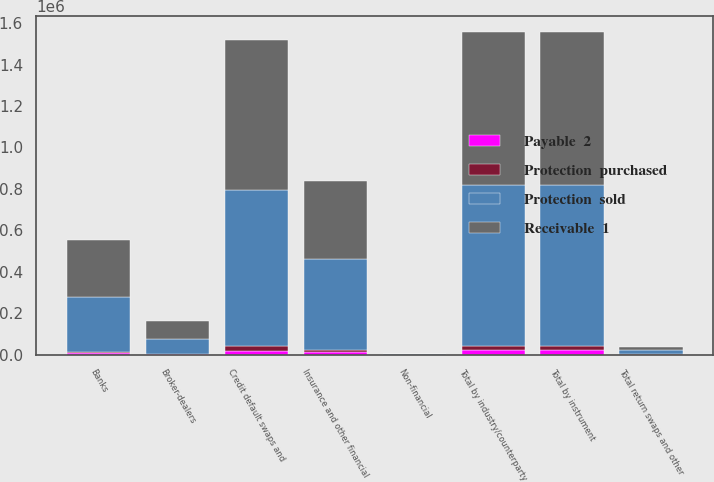<chart> <loc_0><loc_0><loc_500><loc_500><stacked_bar_chart><ecel><fcel>Banks<fcel>Broker-dealers<fcel>Non-financial<fcel>Insurance and other financial<fcel>Total by industry/counterparty<fcel>Credit default swaps and<fcel>Total return swaps and other<fcel>Total by instrument<nl><fcel>Payable  2<fcel>7471<fcel>2325<fcel>70<fcel>10668<fcel>20534<fcel>20251<fcel>283<fcel>20534<nl><fcel>Protection  purchased<fcel>6669<fcel>2285<fcel>91<fcel>12488<fcel>21533<fcel>20554<fcel>979<fcel>21533<nl><fcel>Protection  sold<fcel>264414<fcel>73273<fcel>1288<fcel>438738<fcel>777713<fcel>754114<fcel>23599<fcel>777713<nl><fcel>Receivable  1<fcel>273711<fcel>83229<fcel>1140<fcel>377062<fcel>735142<fcel>724228<fcel>10914<fcel>735142<nl></chart> 